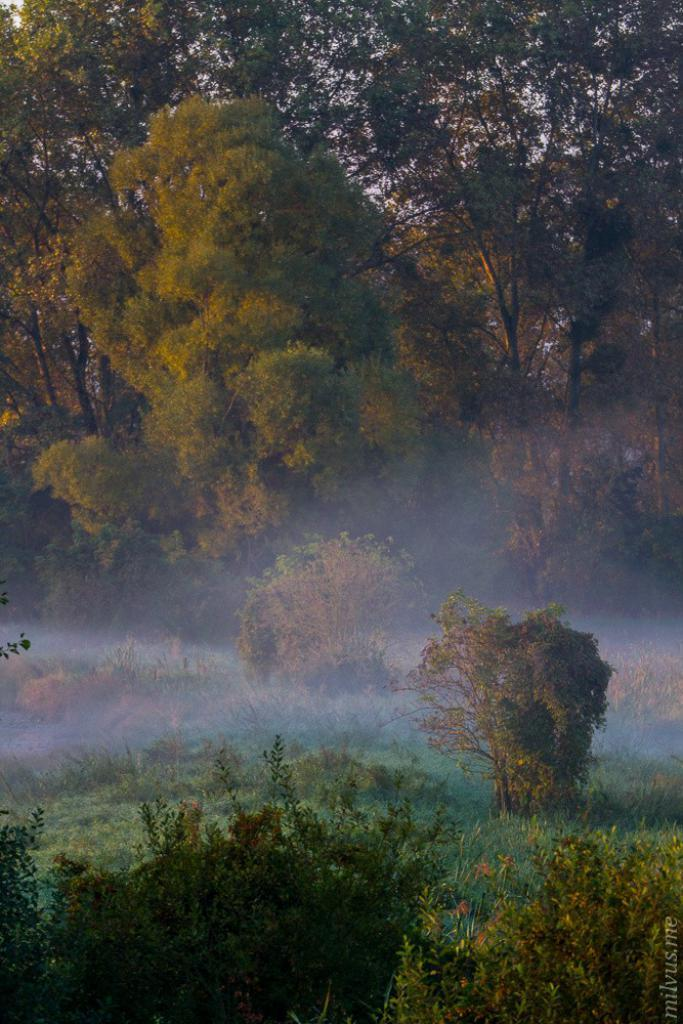What is present on the ground in the image? There are plants on the ground in the image. What type of animal can be seen in the image? There is a dog in the image. What can be seen in the distance in the image? There are trees in the background of the image. What type of quilt is being used to cover the dog in the image? There is no quilt present in the image; the dog is not covered by any fabric. 